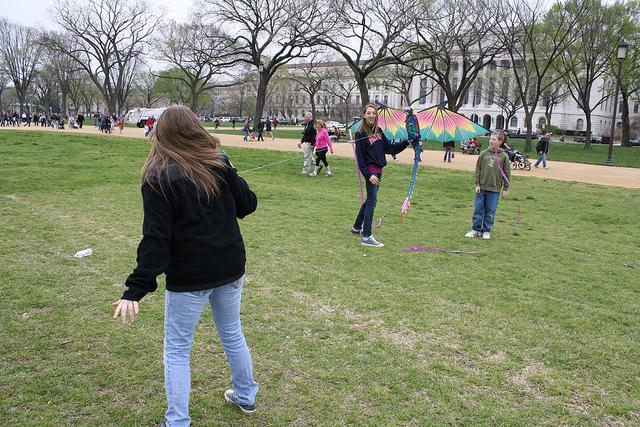What would you likely put in the thing on the ground that looks like garbage? water 